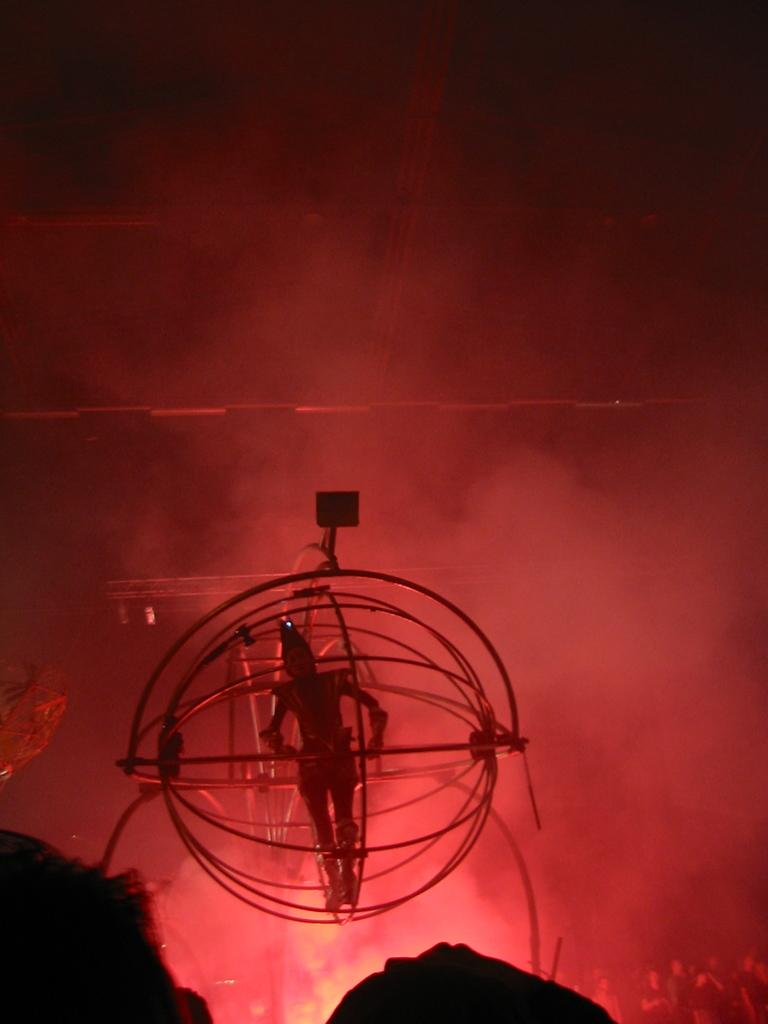What is the main subject of the image? The main subject of the image is a person performing. Where is the person performing from? The person is inside a ball-shaped object. Who can be seen observing the performance? There are people observing the performance at the bottom of the image. What type of oven is being used to blow air into the ball-shaped object? There is no oven or blowing of air present in the image; the person is simply performing inside the ball-shaped object. 